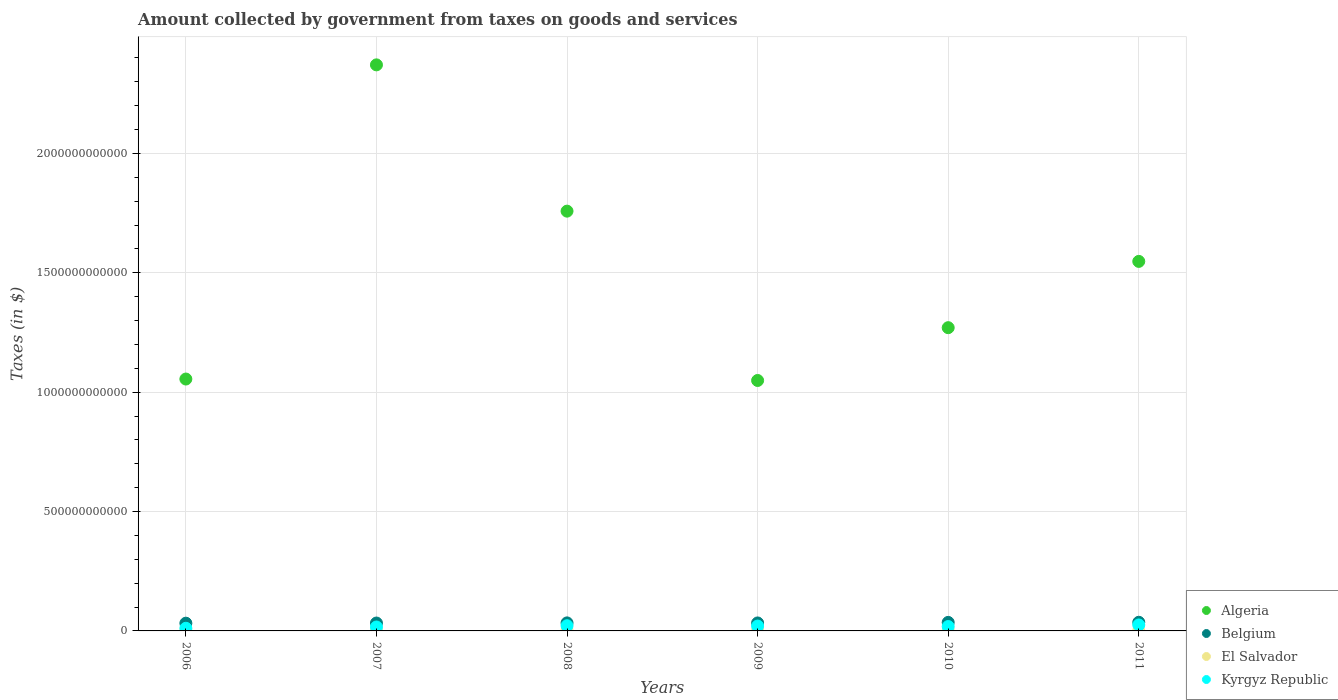How many different coloured dotlines are there?
Ensure brevity in your answer.  4. What is the amount collected by government from taxes on goods and services in El Salvador in 2011?
Provide a short and direct response. 1.69e+09. Across all years, what is the maximum amount collected by government from taxes on goods and services in El Salvador?
Your answer should be compact. 1.80e+09. Across all years, what is the minimum amount collected by government from taxes on goods and services in Kyrgyz Republic?
Your response must be concise. 1.11e+1. In which year was the amount collected by government from taxes on goods and services in El Salvador maximum?
Provide a short and direct response. 2008. What is the total amount collected by government from taxes on goods and services in Kyrgyz Republic in the graph?
Offer a very short reply. 1.13e+11. What is the difference between the amount collected by government from taxes on goods and services in El Salvador in 2007 and that in 2011?
Your response must be concise. -3.50e+07. What is the difference between the amount collected by government from taxes on goods and services in Algeria in 2007 and the amount collected by government from taxes on goods and services in Belgium in 2010?
Give a very brief answer. 2.34e+12. What is the average amount collected by government from taxes on goods and services in Kyrgyz Republic per year?
Offer a very short reply. 1.88e+1. In the year 2008, what is the difference between the amount collected by government from taxes on goods and services in Belgium and amount collected by government from taxes on goods and services in Kyrgyz Republic?
Provide a succinct answer. 1.19e+1. What is the ratio of the amount collected by government from taxes on goods and services in El Salvador in 2006 to that in 2011?
Offer a very short reply. 0.87. What is the difference between the highest and the second highest amount collected by government from taxes on goods and services in Algeria?
Keep it short and to the point. 6.13e+11. What is the difference between the highest and the lowest amount collected by government from taxes on goods and services in El Salvador?
Give a very brief answer. 3.62e+08. Is it the case that in every year, the sum of the amount collected by government from taxes on goods and services in Belgium and amount collected by government from taxes on goods and services in Algeria  is greater than the sum of amount collected by government from taxes on goods and services in Kyrgyz Republic and amount collected by government from taxes on goods and services in El Salvador?
Make the answer very short. Yes. Is it the case that in every year, the sum of the amount collected by government from taxes on goods and services in Belgium and amount collected by government from taxes on goods and services in Algeria  is greater than the amount collected by government from taxes on goods and services in Kyrgyz Republic?
Provide a short and direct response. Yes. Does the amount collected by government from taxes on goods and services in Kyrgyz Republic monotonically increase over the years?
Keep it short and to the point. No. Is the amount collected by government from taxes on goods and services in El Salvador strictly greater than the amount collected by government from taxes on goods and services in Belgium over the years?
Your response must be concise. No. Is the amount collected by government from taxes on goods and services in Belgium strictly less than the amount collected by government from taxes on goods and services in Kyrgyz Republic over the years?
Offer a very short reply. No. How many years are there in the graph?
Your answer should be very brief. 6. What is the difference between two consecutive major ticks on the Y-axis?
Offer a very short reply. 5.00e+11. Does the graph contain grids?
Provide a succinct answer. Yes. Where does the legend appear in the graph?
Provide a succinct answer. Bottom right. How many legend labels are there?
Your answer should be very brief. 4. What is the title of the graph?
Your response must be concise. Amount collected by government from taxes on goods and services. Does "Venezuela" appear as one of the legend labels in the graph?
Your response must be concise. No. What is the label or title of the X-axis?
Your response must be concise. Years. What is the label or title of the Y-axis?
Offer a very short reply. Taxes (in $). What is the Taxes (in $) in Algeria in 2006?
Give a very brief answer. 1.05e+12. What is the Taxes (in $) in Belgium in 2006?
Ensure brevity in your answer.  3.24e+1. What is the Taxes (in $) of El Salvador in 2006?
Give a very brief answer. 1.47e+09. What is the Taxes (in $) in Kyrgyz Republic in 2006?
Offer a very short reply. 1.11e+1. What is the Taxes (in $) of Algeria in 2007?
Your answer should be very brief. 2.37e+12. What is the Taxes (in $) of Belgium in 2007?
Keep it short and to the point. 3.31e+1. What is the Taxes (in $) in El Salvador in 2007?
Offer a very short reply. 1.66e+09. What is the Taxes (in $) of Kyrgyz Republic in 2007?
Your answer should be compact. 1.64e+1. What is the Taxes (in $) in Algeria in 2008?
Make the answer very short. 1.76e+12. What is the Taxes (in $) in Belgium in 2008?
Your response must be concise. 3.36e+1. What is the Taxes (in $) in El Salvador in 2008?
Ensure brevity in your answer.  1.80e+09. What is the Taxes (in $) in Kyrgyz Republic in 2008?
Ensure brevity in your answer.  2.18e+1. What is the Taxes (in $) of Algeria in 2009?
Make the answer very short. 1.05e+12. What is the Taxes (in $) of Belgium in 2009?
Offer a terse response. 3.34e+1. What is the Taxes (in $) of El Salvador in 2009?
Make the answer very short. 1.44e+09. What is the Taxes (in $) in Kyrgyz Republic in 2009?
Your answer should be compact. 2.04e+1. What is the Taxes (in $) of Algeria in 2010?
Give a very brief answer. 1.27e+12. What is the Taxes (in $) of Belgium in 2010?
Ensure brevity in your answer.  3.57e+1. What is the Taxes (in $) of El Salvador in 2010?
Offer a very short reply. 1.66e+09. What is the Taxes (in $) in Kyrgyz Republic in 2010?
Provide a short and direct response. 1.84e+1. What is the Taxes (in $) of Algeria in 2011?
Provide a short and direct response. 1.55e+12. What is the Taxes (in $) in Belgium in 2011?
Offer a terse response. 3.62e+1. What is the Taxes (in $) of El Salvador in 2011?
Your answer should be very brief. 1.69e+09. What is the Taxes (in $) of Kyrgyz Republic in 2011?
Offer a very short reply. 2.50e+1. Across all years, what is the maximum Taxes (in $) of Algeria?
Offer a terse response. 2.37e+12. Across all years, what is the maximum Taxes (in $) in Belgium?
Make the answer very short. 3.62e+1. Across all years, what is the maximum Taxes (in $) in El Salvador?
Provide a short and direct response. 1.80e+09. Across all years, what is the maximum Taxes (in $) in Kyrgyz Republic?
Provide a short and direct response. 2.50e+1. Across all years, what is the minimum Taxes (in $) of Algeria?
Offer a terse response. 1.05e+12. Across all years, what is the minimum Taxes (in $) of Belgium?
Offer a very short reply. 3.24e+1. Across all years, what is the minimum Taxes (in $) of El Salvador?
Provide a succinct answer. 1.44e+09. Across all years, what is the minimum Taxes (in $) in Kyrgyz Republic?
Your answer should be very brief. 1.11e+1. What is the total Taxes (in $) in Algeria in the graph?
Make the answer very short. 9.05e+12. What is the total Taxes (in $) of Belgium in the graph?
Offer a terse response. 2.04e+11. What is the total Taxes (in $) in El Salvador in the graph?
Your response must be concise. 9.73e+09. What is the total Taxes (in $) in Kyrgyz Republic in the graph?
Provide a short and direct response. 1.13e+11. What is the difference between the Taxes (in $) of Algeria in 2006 and that in 2007?
Provide a succinct answer. -1.32e+12. What is the difference between the Taxes (in $) of Belgium in 2006 and that in 2007?
Give a very brief answer. -6.23e+08. What is the difference between the Taxes (in $) in El Salvador in 2006 and that in 2007?
Keep it short and to the point. -1.86e+08. What is the difference between the Taxes (in $) of Kyrgyz Republic in 2006 and that in 2007?
Your answer should be very brief. -5.34e+09. What is the difference between the Taxes (in $) in Algeria in 2006 and that in 2008?
Your answer should be very brief. -7.03e+11. What is the difference between the Taxes (in $) of Belgium in 2006 and that in 2008?
Keep it short and to the point. -1.22e+09. What is the difference between the Taxes (in $) in El Salvador in 2006 and that in 2008?
Ensure brevity in your answer.  -3.30e+08. What is the difference between the Taxes (in $) of Kyrgyz Republic in 2006 and that in 2008?
Your answer should be compact. -1.07e+1. What is the difference between the Taxes (in $) in Algeria in 2006 and that in 2009?
Ensure brevity in your answer.  6.04e+09. What is the difference between the Taxes (in $) in Belgium in 2006 and that in 2009?
Your response must be concise. -9.86e+08. What is the difference between the Taxes (in $) in El Salvador in 2006 and that in 2009?
Provide a short and direct response. 3.19e+07. What is the difference between the Taxes (in $) in Kyrgyz Republic in 2006 and that in 2009?
Keep it short and to the point. -9.27e+09. What is the difference between the Taxes (in $) in Algeria in 2006 and that in 2010?
Offer a terse response. -2.15e+11. What is the difference between the Taxes (in $) of Belgium in 2006 and that in 2010?
Offer a terse response. -3.27e+09. What is the difference between the Taxes (in $) in El Salvador in 2006 and that in 2010?
Keep it short and to the point. -1.89e+08. What is the difference between the Taxes (in $) in Kyrgyz Republic in 2006 and that in 2010?
Your answer should be very brief. -7.29e+09. What is the difference between the Taxes (in $) in Algeria in 2006 and that in 2011?
Offer a terse response. -4.93e+11. What is the difference between the Taxes (in $) of Belgium in 2006 and that in 2011?
Give a very brief answer. -3.77e+09. What is the difference between the Taxes (in $) in El Salvador in 2006 and that in 2011?
Offer a terse response. -2.21e+08. What is the difference between the Taxes (in $) in Kyrgyz Republic in 2006 and that in 2011?
Ensure brevity in your answer.  -1.39e+1. What is the difference between the Taxes (in $) in Algeria in 2007 and that in 2008?
Give a very brief answer. 6.13e+11. What is the difference between the Taxes (in $) in Belgium in 2007 and that in 2008?
Ensure brevity in your answer.  -5.92e+08. What is the difference between the Taxes (in $) in El Salvador in 2007 and that in 2008?
Make the answer very short. -1.44e+08. What is the difference between the Taxes (in $) in Kyrgyz Republic in 2007 and that in 2008?
Make the answer very short. -5.35e+09. What is the difference between the Taxes (in $) of Algeria in 2007 and that in 2009?
Your response must be concise. 1.32e+12. What is the difference between the Taxes (in $) of Belgium in 2007 and that in 2009?
Ensure brevity in your answer.  -3.62e+08. What is the difference between the Taxes (in $) of El Salvador in 2007 and that in 2009?
Make the answer very short. 2.18e+08. What is the difference between the Taxes (in $) in Kyrgyz Republic in 2007 and that in 2009?
Offer a terse response. -3.93e+09. What is the difference between the Taxes (in $) in Algeria in 2007 and that in 2010?
Keep it short and to the point. 1.10e+12. What is the difference between the Taxes (in $) in Belgium in 2007 and that in 2010?
Your response must be concise. -2.65e+09. What is the difference between the Taxes (in $) in El Salvador in 2007 and that in 2010?
Ensure brevity in your answer.  -2.90e+06. What is the difference between the Taxes (in $) in Kyrgyz Republic in 2007 and that in 2010?
Ensure brevity in your answer.  -1.95e+09. What is the difference between the Taxes (in $) in Algeria in 2007 and that in 2011?
Your answer should be very brief. 8.23e+11. What is the difference between the Taxes (in $) in Belgium in 2007 and that in 2011?
Ensure brevity in your answer.  -3.14e+09. What is the difference between the Taxes (in $) in El Salvador in 2007 and that in 2011?
Give a very brief answer. -3.50e+07. What is the difference between the Taxes (in $) of Kyrgyz Republic in 2007 and that in 2011?
Provide a short and direct response. -8.56e+09. What is the difference between the Taxes (in $) of Algeria in 2008 and that in 2009?
Your response must be concise. 7.09e+11. What is the difference between the Taxes (in $) of Belgium in 2008 and that in 2009?
Make the answer very short. 2.30e+08. What is the difference between the Taxes (in $) of El Salvador in 2008 and that in 2009?
Give a very brief answer. 3.62e+08. What is the difference between the Taxes (in $) in Kyrgyz Republic in 2008 and that in 2009?
Your response must be concise. 1.42e+09. What is the difference between the Taxes (in $) of Algeria in 2008 and that in 2010?
Offer a very short reply. 4.88e+11. What is the difference between the Taxes (in $) in Belgium in 2008 and that in 2010?
Provide a succinct answer. -2.06e+09. What is the difference between the Taxes (in $) of El Salvador in 2008 and that in 2010?
Your answer should be compact. 1.41e+08. What is the difference between the Taxes (in $) in Kyrgyz Republic in 2008 and that in 2010?
Offer a terse response. 3.40e+09. What is the difference between the Taxes (in $) of Algeria in 2008 and that in 2011?
Provide a succinct answer. 2.10e+11. What is the difference between the Taxes (in $) in Belgium in 2008 and that in 2011?
Give a very brief answer. -2.55e+09. What is the difference between the Taxes (in $) of El Salvador in 2008 and that in 2011?
Your answer should be compact. 1.09e+08. What is the difference between the Taxes (in $) of Kyrgyz Republic in 2008 and that in 2011?
Your answer should be compact. -3.21e+09. What is the difference between the Taxes (in $) of Algeria in 2009 and that in 2010?
Your answer should be very brief. -2.21e+11. What is the difference between the Taxes (in $) in Belgium in 2009 and that in 2010?
Your answer should be compact. -2.29e+09. What is the difference between the Taxes (in $) of El Salvador in 2009 and that in 2010?
Provide a short and direct response. -2.20e+08. What is the difference between the Taxes (in $) in Kyrgyz Republic in 2009 and that in 2010?
Offer a very short reply. 1.98e+09. What is the difference between the Taxes (in $) in Algeria in 2009 and that in 2011?
Your answer should be very brief. -4.99e+11. What is the difference between the Taxes (in $) of Belgium in 2009 and that in 2011?
Ensure brevity in your answer.  -2.78e+09. What is the difference between the Taxes (in $) in El Salvador in 2009 and that in 2011?
Offer a very short reply. -2.53e+08. What is the difference between the Taxes (in $) of Kyrgyz Republic in 2009 and that in 2011?
Give a very brief answer. -4.63e+09. What is the difference between the Taxes (in $) of Algeria in 2010 and that in 2011?
Ensure brevity in your answer.  -2.78e+11. What is the difference between the Taxes (in $) in Belgium in 2010 and that in 2011?
Offer a terse response. -4.96e+08. What is the difference between the Taxes (in $) of El Salvador in 2010 and that in 2011?
Your response must be concise. -3.20e+07. What is the difference between the Taxes (in $) in Kyrgyz Republic in 2010 and that in 2011?
Provide a succinct answer. -6.61e+09. What is the difference between the Taxes (in $) of Algeria in 2006 and the Taxes (in $) of Belgium in 2007?
Offer a very short reply. 1.02e+12. What is the difference between the Taxes (in $) in Algeria in 2006 and the Taxes (in $) in El Salvador in 2007?
Give a very brief answer. 1.05e+12. What is the difference between the Taxes (in $) in Algeria in 2006 and the Taxes (in $) in Kyrgyz Republic in 2007?
Your answer should be compact. 1.04e+12. What is the difference between the Taxes (in $) in Belgium in 2006 and the Taxes (in $) in El Salvador in 2007?
Ensure brevity in your answer.  3.08e+1. What is the difference between the Taxes (in $) of Belgium in 2006 and the Taxes (in $) of Kyrgyz Republic in 2007?
Your answer should be very brief. 1.60e+1. What is the difference between the Taxes (in $) in El Salvador in 2006 and the Taxes (in $) in Kyrgyz Republic in 2007?
Make the answer very short. -1.50e+1. What is the difference between the Taxes (in $) of Algeria in 2006 and the Taxes (in $) of Belgium in 2008?
Keep it short and to the point. 1.02e+12. What is the difference between the Taxes (in $) of Algeria in 2006 and the Taxes (in $) of El Salvador in 2008?
Provide a short and direct response. 1.05e+12. What is the difference between the Taxes (in $) of Algeria in 2006 and the Taxes (in $) of Kyrgyz Republic in 2008?
Ensure brevity in your answer.  1.03e+12. What is the difference between the Taxes (in $) of Belgium in 2006 and the Taxes (in $) of El Salvador in 2008?
Your answer should be very brief. 3.06e+1. What is the difference between the Taxes (in $) in Belgium in 2006 and the Taxes (in $) in Kyrgyz Republic in 2008?
Ensure brevity in your answer.  1.06e+1. What is the difference between the Taxes (in $) of El Salvador in 2006 and the Taxes (in $) of Kyrgyz Republic in 2008?
Keep it short and to the point. -2.03e+1. What is the difference between the Taxes (in $) in Algeria in 2006 and the Taxes (in $) in Belgium in 2009?
Your answer should be very brief. 1.02e+12. What is the difference between the Taxes (in $) in Algeria in 2006 and the Taxes (in $) in El Salvador in 2009?
Make the answer very short. 1.05e+12. What is the difference between the Taxes (in $) in Algeria in 2006 and the Taxes (in $) in Kyrgyz Republic in 2009?
Offer a very short reply. 1.03e+12. What is the difference between the Taxes (in $) of Belgium in 2006 and the Taxes (in $) of El Salvador in 2009?
Make the answer very short. 3.10e+1. What is the difference between the Taxes (in $) in Belgium in 2006 and the Taxes (in $) in Kyrgyz Republic in 2009?
Provide a succinct answer. 1.21e+1. What is the difference between the Taxes (in $) in El Salvador in 2006 and the Taxes (in $) in Kyrgyz Republic in 2009?
Offer a very short reply. -1.89e+1. What is the difference between the Taxes (in $) of Algeria in 2006 and the Taxes (in $) of Belgium in 2010?
Your answer should be compact. 1.02e+12. What is the difference between the Taxes (in $) of Algeria in 2006 and the Taxes (in $) of El Salvador in 2010?
Your answer should be very brief. 1.05e+12. What is the difference between the Taxes (in $) in Algeria in 2006 and the Taxes (in $) in Kyrgyz Republic in 2010?
Your answer should be compact. 1.04e+12. What is the difference between the Taxes (in $) of Belgium in 2006 and the Taxes (in $) of El Salvador in 2010?
Make the answer very short. 3.08e+1. What is the difference between the Taxes (in $) in Belgium in 2006 and the Taxes (in $) in Kyrgyz Republic in 2010?
Make the answer very short. 1.40e+1. What is the difference between the Taxes (in $) in El Salvador in 2006 and the Taxes (in $) in Kyrgyz Republic in 2010?
Your response must be concise. -1.69e+1. What is the difference between the Taxes (in $) of Algeria in 2006 and the Taxes (in $) of Belgium in 2011?
Your answer should be very brief. 1.02e+12. What is the difference between the Taxes (in $) of Algeria in 2006 and the Taxes (in $) of El Salvador in 2011?
Make the answer very short. 1.05e+12. What is the difference between the Taxes (in $) of Algeria in 2006 and the Taxes (in $) of Kyrgyz Republic in 2011?
Give a very brief answer. 1.03e+12. What is the difference between the Taxes (in $) in Belgium in 2006 and the Taxes (in $) in El Salvador in 2011?
Your answer should be very brief. 3.07e+1. What is the difference between the Taxes (in $) of Belgium in 2006 and the Taxes (in $) of Kyrgyz Republic in 2011?
Give a very brief answer. 7.43e+09. What is the difference between the Taxes (in $) in El Salvador in 2006 and the Taxes (in $) in Kyrgyz Republic in 2011?
Your answer should be compact. -2.35e+1. What is the difference between the Taxes (in $) in Algeria in 2007 and the Taxes (in $) in Belgium in 2008?
Offer a terse response. 2.34e+12. What is the difference between the Taxes (in $) in Algeria in 2007 and the Taxes (in $) in El Salvador in 2008?
Ensure brevity in your answer.  2.37e+12. What is the difference between the Taxes (in $) in Algeria in 2007 and the Taxes (in $) in Kyrgyz Republic in 2008?
Your answer should be compact. 2.35e+12. What is the difference between the Taxes (in $) in Belgium in 2007 and the Taxes (in $) in El Salvador in 2008?
Your response must be concise. 3.12e+1. What is the difference between the Taxes (in $) in Belgium in 2007 and the Taxes (in $) in Kyrgyz Republic in 2008?
Make the answer very short. 1.13e+1. What is the difference between the Taxes (in $) of El Salvador in 2007 and the Taxes (in $) of Kyrgyz Republic in 2008?
Keep it short and to the point. -2.01e+1. What is the difference between the Taxes (in $) in Algeria in 2007 and the Taxes (in $) in Belgium in 2009?
Provide a succinct answer. 2.34e+12. What is the difference between the Taxes (in $) in Algeria in 2007 and the Taxes (in $) in El Salvador in 2009?
Your answer should be compact. 2.37e+12. What is the difference between the Taxes (in $) of Algeria in 2007 and the Taxes (in $) of Kyrgyz Republic in 2009?
Keep it short and to the point. 2.35e+12. What is the difference between the Taxes (in $) of Belgium in 2007 and the Taxes (in $) of El Salvador in 2009?
Keep it short and to the point. 3.16e+1. What is the difference between the Taxes (in $) in Belgium in 2007 and the Taxes (in $) in Kyrgyz Republic in 2009?
Provide a succinct answer. 1.27e+1. What is the difference between the Taxes (in $) of El Salvador in 2007 and the Taxes (in $) of Kyrgyz Republic in 2009?
Offer a terse response. -1.87e+1. What is the difference between the Taxes (in $) of Algeria in 2007 and the Taxes (in $) of Belgium in 2010?
Ensure brevity in your answer.  2.34e+12. What is the difference between the Taxes (in $) of Algeria in 2007 and the Taxes (in $) of El Salvador in 2010?
Ensure brevity in your answer.  2.37e+12. What is the difference between the Taxes (in $) of Algeria in 2007 and the Taxes (in $) of Kyrgyz Republic in 2010?
Offer a terse response. 2.35e+12. What is the difference between the Taxes (in $) of Belgium in 2007 and the Taxes (in $) of El Salvador in 2010?
Provide a short and direct response. 3.14e+1. What is the difference between the Taxes (in $) of Belgium in 2007 and the Taxes (in $) of Kyrgyz Republic in 2010?
Give a very brief answer. 1.47e+1. What is the difference between the Taxes (in $) in El Salvador in 2007 and the Taxes (in $) in Kyrgyz Republic in 2010?
Offer a terse response. -1.67e+1. What is the difference between the Taxes (in $) of Algeria in 2007 and the Taxes (in $) of Belgium in 2011?
Your response must be concise. 2.33e+12. What is the difference between the Taxes (in $) of Algeria in 2007 and the Taxes (in $) of El Salvador in 2011?
Offer a very short reply. 2.37e+12. What is the difference between the Taxes (in $) in Algeria in 2007 and the Taxes (in $) in Kyrgyz Republic in 2011?
Ensure brevity in your answer.  2.35e+12. What is the difference between the Taxes (in $) of Belgium in 2007 and the Taxes (in $) of El Salvador in 2011?
Offer a terse response. 3.14e+1. What is the difference between the Taxes (in $) in Belgium in 2007 and the Taxes (in $) in Kyrgyz Republic in 2011?
Make the answer very short. 8.05e+09. What is the difference between the Taxes (in $) in El Salvador in 2007 and the Taxes (in $) in Kyrgyz Republic in 2011?
Give a very brief answer. -2.33e+1. What is the difference between the Taxes (in $) of Algeria in 2008 and the Taxes (in $) of Belgium in 2009?
Give a very brief answer. 1.72e+12. What is the difference between the Taxes (in $) of Algeria in 2008 and the Taxes (in $) of El Salvador in 2009?
Provide a succinct answer. 1.76e+12. What is the difference between the Taxes (in $) in Algeria in 2008 and the Taxes (in $) in Kyrgyz Republic in 2009?
Keep it short and to the point. 1.74e+12. What is the difference between the Taxes (in $) in Belgium in 2008 and the Taxes (in $) in El Salvador in 2009?
Keep it short and to the point. 3.22e+1. What is the difference between the Taxes (in $) in Belgium in 2008 and the Taxes (in $) in Kyrgyz Republic in 2009?
Provide a succinct answer. 1.33e+1. What is the difference between the Taxes (in $) in El Salvador in 2008 and the Taxes (in $) in Kyrgyz Republic in 2009?
Your answer should be compact. -1.86e+1. What is the difference between the Taxes (in $) of Algeria in 2008 and the Taxes (in $) of Belgium in 2010?
Provide a short and direct response. 1.72e+12. What is the difference between the Taxes (in $) in Algeria in 2008 and the Taxes (in $) in El Salvador in 2010?
Your answer should be compact. 1.76e+12. What is the difference between the Taxes (in $) of Algeria in 2008 and the Taxes (in $) of Kyrgyz Republic in 2010?
Your answer should be compact. 1.74e+12. What is the difference between the Taxes (in $) in Belgium in 2008 and the Taxes (in $) in El Salvador in 2010?
Offer a very short reply. 3.20e+1. What is the difference between the Taxes (in $) in Belgium in 2008 and the Taxes (in $) in Kyrgyz Republic in 2010?
Offer a terse response. 1.53e+1. What is the difference between the Taxes (in $) of El Salvador in 2008 and the Taxes (in $) of Kyrgyz Republic in 2010?
Give a very brief answer. -1.66e+1. What is the difference between the Taxes (in $) of Algeria in 2008 and the Taxes (in $) of Belgium in 2011?
Provide a short and direct response. 1.72e+12. What is the difference between the Taxes (in $) in Algeria in 2008 and the Taxes (in $) in El Salvador in 2011?
Your answer should be very brief. 1.76e+12. What is the difference between the Taxes (in $) of Algeria in 2008 and the Taxes (in $) of Kyrgyz Republic in 2011?
Provide a short and direct response. 1.73e+12. What is the difference between the Taxes (in $) of Belgium in 2008 and the Taxes (in $) of El Salvador in 2011?
Provide a short and direct response. 3.20e+1. What is the difference between the Taxes (in $) in Belgium in 2008 and the Taxes (in $) in Kyrgyz Republic in 2011?
Your response must be concise. 8.64e+09. What is the difference between the Taxes (in $) in El Salvador in 2008 and the Taxes (in $) in Kyrgyz Republic in 2011?
Keep it short and to the point. -2.32e+1. What is the difference between the Taxes (in $) in Algeria in 2009 and the Taxes (in $) in Belgium in 2010?
Your answer should be very brief. 1.01e+12. What is the difference between the Taxes (in $) of Algeria in 2009 and the Taxes (in $) of El Salvador in 2010?
Offer a terse response. 1.05e+12. What is the difference between the Taxes (in $) of Algeria in 2009 and the Taxes (in $) of Kyrgyz Republic in 2010?
Ensure brevity in your answer.  1.03e+12. What is the difference between the Taxes (in $) in Belgium in 2009 and the Taxes (in $) in El Salvador in 2010?
Keep it short and to the point. 3.18e+1. What is the difference between the Taxes (in $) in Belgium in 2009 and the Taxes (in $) in Kyrgyz Republic in 2010?
Your answer should be very brief. 1.50e+1. What is the difference between the Taxes (in $) of El Salvador in 2009 and the Taxes (in $) of Kyrgyz Republic in 2010?
Provide a short and direct response. -1.69e+1. What is the difference between the Taxes (in $) in Algeria in 2009 and the Taxes (in $) in Belgium in 2011?
Provide a succinct answer. 1.01e+12. What is the difference between the Taxes (in $) in Algeria in 2009 and the Taxes (in $) in El Salvador in 2011?
Offer a very short reply. 1.05e+12. What is the difference between the Taxes (in $) in Algeria in 2009 and the Taxes (in $) in Kyrgyz Republic in 2011?
Provide a short and direct response. 1.02e+12. What is the difference between the Taxes (in $) of Belgium in 2009 and the Taxes (in $) of El Salvador in 2011?
Give a very brief answer. 3.17e+1. What is the difference between the Taxes (in $) in Belgium in 2009 and the Taxes (in $) in Kyrgyz Republic in 2011?
Give a very brief answer. 8.41e+09. What is the difference between the Taxes (in $) in El Salvador in 2009 and the Taxes (in $) in Kyrgyz Republic in 2011?
Provide a succinct answer. -2.36e+1. What is the difference between the Taxes (in $) of Algeria in 2010 and the Taxes (in $) of Belgium in 2011?
Keep it short and to the point. 1.23e+12. What is the difference between the Taxes (in $) in Algeria in 2010 and the Taxes (in $) in El Salvador in 2011?
Give a very brief answer. 1.27e+12. What is the difference between the Taxes (in $) in Algeria in 2010 and the Taxes (in $) in Kyrgyz Republic in 2011?
Give a very brief answer. 1.25e+12. What is the difference between the Taxes (in $) of Belgium in 2010 and the Taxes (in $) of El Salvador in 2011?
Make the answer very short. 3.40e+1. What is the difference between the Taxes (in $) in Belgium in 2010 and the Taxes (in $) in Kyrgyz Republic in 2011?
Provide a short and direct response. 1.07e+1. What is the difference between the Taxes (in $) of El Salvador in 2010 and the Taxes (in $) of Kyrgyz Republic in 2011?
Give a very brief answer. -2.33e+1. What is the average Taxes (in $) in Algeria per year?
Provide a short and direct response. 1.51e+12. What is the average Taxes (in $) of Belgium per year?
Offer a terse response. 3.41e+1. What is the average Taxes (in $) in El Salvador per year?
Your answer should be compact. 1.62e+09. What is the average Taxes (in $) of Kyrgyz Republic per year?
Provide a succinct answer. 1.88e+1. In the year 2006, what is the difference between the Taxes (in $) in Algeria and Taxes (in $) in Belgium?
Offer a terse response. 1.02e+12. In the year 2006, what is the difference between the Taxes (in $) in Algeria and Taxes (in $) in El Salvador?
Ensure brevity in your answer.  1.05e+12. In the year 2006, what is the difference between the Taxes (in $) in Algeria and Taxes (in $) in Kyrgyz Republic?
Make the answer very short. 1.04e+12. In the year 2006, what is the difference between the Taxes (in $) of Belgium and Taxes (in $) of El Salvador?
Offer a terse response. 3.10e+1. In the year 2006, what is the difference between the Taxes (in $) in Belgium and Taxes (in $) in Kyrgyz Republic?
Provide a succinct answer. 2.13e+1. In the year 2006, what is the difference between the Taxes (in $) of El Salvador and Taxes (in $) of Kyrgyz Republic?
Offer a terse response. -9.63e+09. In the year 2007, what is the difference between the Taxes (in $) in Algeria and Taxes (in $) in Belgium?
Your answer should be very brief. 2.34e+12. In the year 2007, what is the difference between the Taxes (in $) of Algeria and Taxes (in $) of El Salvador?
Offer a terse response. 2.37e+12. In the year 2007, what is the difference between the Taxes (in $) of Algeria and Taxes (in $) of Kyrgyz Republic?
Give a very brief answer. 2.35e+12. In the year 2007, what is the difference between the Taxes (in $) of Belgium and Taxes (in $) of El Salvador?
Your answer should be compact. 3.14e+1. In the year 2007, what is the difference between the Taxes (in $) in Belgium and Taxes (in $) in Kyrgyz Republic?
Provide a succinct answer. 1.66e+1. In the year 2007, what is the difference between the Taxes (in $) in El Salvador and Taxes (in $) in Kyrgyz Republic?
Provide a short and direct response. -1.48e+1. In the year 2008, what is the difference between the Taxes (in $) of Algeria and Taxes (in $) of Belgium?
Ensure brevity in your answer.  1.72e+12. In the year 2008, what is the difference between the Taxes (in $) of Algeria and Taxes (in $) of El Salvador?
Make the answer very short. 1.76e+12. In the year 2008, what is the difference between the Taxes (in $) of Algeria and Taxes (in $) of Kyrgyz Republic?
Your answer should be compact. 1.74e+12. In the year 2008, what is the difference between the Taxes (in $) in Belgium and Taxes (in $) in El Salvador?
Keep it short and to the point. 3.18e+1. In the year 2008, what is the difference between the Taxes (in $) of Belgium and Taxes (in $) of Kyrgyz Republic?
Keep it short and to the point. 1.19e+1. In the year 2008, what is the difference between the Taxes (in $) in El Salvador and Taxes (in $) in Kyrgyz Republic?
Give a very brief answer. -2.00e+1. In the year 2009, what is the difference between the Taxes (in $) in Algeria and Taxes (in $) in Belgium?
Make the answer very short. 1.02e+12. In the year 2009, what is the difference between the Taxes (in $) in Algeria and Taxes (in $) in El Salvador?
Make the answer very short. 1.05e+12. In the year 2009, what is the difference between the Taxes (in $) in Algeria and Taxes (in $) in Kyrgyz Republic?
Offer a very short reply. 1.03e+12. In the year 2009, what is the difference between the Taxes (in $) in Belgium and Taxes (in $) in El Salvador?
Give a very brief answer. 3.20e+1. In the year 2009, what is the difference between the Taxes (in $) of Belgium and Taxes (in $) of Kyrgyz Republic?
Offer a terse response. 1.30e+1. In the year 2009, what is the difference between the Taxes (in $) of El Salvador and Taxes (in $) of Kyrgyz Republic?
Your answer should be compact. -1.89e+1. In the year 2010, what is the difference between the Taxes (in $) in Algeria and Taxes (in $) in Belgium?
Keep it short and to the point. 1.23e+12. In the year 2010, what is the difference between the Taxes (in $) of Algeria and Taxes (in $) of El Salvador?
Give a very brief answer. 1.27e+12. In the year 2010, what is the difference between the Taxes (in $) of Algeria and Taxes (in $) of Kyrgyz Republic?
Ensure brevity in your answer.  1.25e+12. In the year 2010, what is the difference between the Taxes (in $) of Belgium and Taxes (in $) of El Salvador?
Keep it short and to the point. 3.40e+1. In the year 2010, what is the difference between the Taxes (in $) of Belgium and Taxes (in $) of Kyrgyz Republic?
Your answer should be very brief. 1.73e+1. In the year 2010, what is the difference between the Taxes (in $) in El Salvador and Taxes (in $) in Kyrgyz Republic?
Your answer should be very brief. -1.67e+1. In the year 2011, what is the difference between the Taxes (in $) of Algeria and Taxes (in $) of Belgium?
Provide a short and direct response. 1.51e+12. In the year 2011, what is the difference between the Taxes (in $) in Algeria and Taxes (in $) in El Salvador?
Ensure brevity in your answer.  1.55e+12. In the year 2011, what is the difference between the Taxes (in $) in Algeria and Taxes (in $) in Kyrgyz Republic?
Provide a succinct answer. 1.52e+12. In the year 2011, what is the difference between the Taxes (in $) of Belgium and Taxes (in $) of El Salvador?
Provide a succinct answer. 3.45e+1. In the year 2011, what is the difference between the Taxes (in $) in Belgium and Taxes (in $) in Kyrgyz Republic?
Ensure brevity in your answer.  1.12e+1. In the year 2011, what is the difference between the Taxes (in $) in El Salvador and Taxes (in $) in Kyrgyz Republic?
Provide a succinct answer. -2.33e+1. What is the ratio of the Taxes (in $) of Algeria in 2006 to that in 2007?
Provide a short and direct response. 0.45. What is the ratio of the Taxes (in $) in Belgium in 2006 to that in 2007?
Provide a succinct answer. 0.98. What is the ratio of the Taxes (in $) in El Salvador in 2006 to that in 2007?
Offer a terse response. 0.89. What is the ratio of the Taxes (in $) in Kyrgyz Republic in 2006 to that in 2007?
Ensure brevity in your answer.  0.68. What is the ratio of the Taxes (in $) of Belgium in 2006 to that in 2008?
Your answer should be compact. 0.96. What is the ratio of the Taxes (in $) of El Salvador in 2006 to that in 2008?
Provide a succinct answer. 0.82. What is the ratio of the Taxes (in $) in Kyrgyz Republic in 2006 to that in 2008?
Your response must be concise. 0.51. What is the ratio of the Taxes (in $) of Algeria in 2006 to that in 2009?
Give a very brief answer. 1.01. What is the ratio of the Taxes (in $) in Belgium in 2006 to that in 2009?
Make the answer very short. 0.97. What is the ratio of the Taxes (in $) of El Salvador in 2006 to that in 2009?
Provide a short and direct response. 1.02. What is the ratio of the Taxes (in $) in Kyrgyz Republic in 2006 to that in 2009?
Offer a terse response. 0.55. What is the ratio of the Taxes (in $) of Algeria in 2006 to that in 2010?
Make the answer very short. 0.83. What is the ratio of the Taxes (in $) of Belgium in 2006 to that in 2010?
Keep it short and to the point. 0.91. What is the ratio of the Taxes (in $) of El Salvador in 2006 to that in 2010?
Make the answer very short. 0.89. What is the ratio of the Taxes (in $) of Kyrgyz Republic in 2006 to that in 2010?
Provide a succinct answer. 0.6. What is the ratio of the Taxes (in $) in Algeria in 2006 to that in 2011?
Provide a succinct answer. 0.68. What is the ratio of the Taxes (in $) of Belgium in 2006 to that in 2011?
Provide a succinct answer. 0.9. What is the ratio of the Taxes (in $) in El Salvador in 2006 to that in 2011?
Ensure brevity in your answer.  0.87. What is the ratio of the Taxes (in $) in Kyrgyz Republic in 2006 to that in 2011?
Ensure brevity in your answer.  0.44. What is the ratio of the Taxes (in $) of Algeria in 2007 to that in 2008?
Ensure brevity in your answer.  1.35. What is the ratio of the Taxes (in $) in Belgium in 2007 to that in 2008?
Your answer should be compact. 0.98. What is the ratio of the Taxes (in $) of El Salvador in 2007 to that in 2008?
Provide a short and direct response. 0.92. What is the ratio of the Taxes (in $) in Kyrgyz Republic in 2007 to that in 2008?
Your answer should be compact. 0.75. What is the ratio of the Taxes (in $) of Algeria in 2007 to that in 2009?
Your answer should be compact. 2.26. What is the ratio of the Taxes (in $) in El Salvador in 2007 to that in 2009?
Keep it short and to the point. 1.15. What is the ratio of the Taxes (in $) of Kyrgyz Republic in 2007 to that in 2009?
Keep it short and to the point. 0.81. What is the ratio of the Taxes (in $) of Algeria in 2007 to that in 2010?
Offer a very short reply. 1.87. What is the ratio of the Taxes (in $) of Belgium in 2007 to that in 2010?
Ensure brevity in your answer.  0.93. What is the ratio of the Taxes (in $) in El Salvador in 2007 to that in 2010?
Your answer should be very brief. 1. What is the ratio of the Taxes (in $) of Kyrgyz Republic in 2007 to that in 2010?
Your answer should be compact. 0.89. What is the ratio of the Taxes (in $) in Algeria in 2007 to that in 2011?
Your answer should be very brief. 1.53. What is the ratio of the Taxes (in $) in Belgium in 2007 to that in 2011?
Your response must be concise. 0.91. What is the ratio of the Taxes (in $) of El Salvador in 2007 to that in 2011?
Provide a succinct answer. 0.98. What is the ratio of the Taxes (in $) in Kyrgyz Republic in 2007 to that in 2011?
Ensure brevity in your answer.  0.66. What is the ratio of the Taxes (in $) of Algeria in 2008 to that in 2009?
Provide a short and direct response. 1.68. What is the ratio of the Taxes (in $) in Belgium in 2008 to that in 2009?
Provide a short and direct response. 1.01. What is the ratio of the Taxes (in $) of El Salvador in 2008 to that in 2009?
Your answer should be compact. 1.25. What is the ratio of the Taxes (in $) in Kyrgyz Republic in 2008 to that in 2009?
Give a very brief answer. 1.07. What is the ratio of the Taxes (in $) of Algeria in 2008 to that in 2010?
Offer a terse response. 1.38. What is the ratio of the Taxes (in $) in Belgium in 2008 to that in 2010?
Offer a terse response. 0.94. What is the ratio of the Taxes (in $) in El Salvador in 2008 to that in 2010?
Keep it short and to the point. 1.09. What is the ratio of the Taxes (in $) in Kyrgyz Republic in 2008 to that in 2010?
Your answer should be compact. 1.18. What is the ratio of the Taxes (in $) in Algeria in 2008 to that in 2011?
Provide a short and direct response. 1.14. What is the ratio of the Taxes (in $) in Belgium in 2008 to that in 2011?
Your answer should be very brief. 0.93. What is the ratio of the Taxes (in $) of El Salvador in 2008 to that in 2011?
Make the answer very short. 1.06. What is the ratio of the Taxes (in $) in Kyrgyz Republic in 2008 to that in 2011?
Keep it short and to the point. 0.87. What is the ratio of the Taxes (in $) of Algeria in 2009 to that in 2010?
Ensure brevity in your answer.  0.83. What is the ratio of the Taxes (in $) of Belgium in 2009 to that in 2010?
Provide a succinct answer. 0.94. What is the ratio of the Taxes (in $) of El Salvador in 2009 to that in 2010?
Provide a succinct answer. 0.87. What is the ratio of the Taxes (in $) of Kyrgyz Republic in 2009 to that in 2010?
Your answer should be compact. 1.11. What is the ratio of the Taxes (in $) of Algeria in 2009 to that in 2011?
Your answer should be very brief. 0.68. What is the ratio of the Taxes (in $) in El Salvador in 2009 to that in 2011?
Make the answer very short. 0.85. What is the ratio of the Taxes (in $) in Kyrgyz Republic in 2009 to that in 2011?
Offer a terse response. 0.81. What is the ratio of the Taxes (in $) in Algeria in 2010 to that in 2011?
Your answer should be very brief. 0.82. What is the ratio of the Taxes (in $) of Belgium in 2010 to that in 2011?
Offer a terse response. 0.99. What is the ratio of the Taxes (in $) of El Salvador in 2010 to that in 2011?
Keep it short and to the point. 0.98. What is the ratio of the Taxes (in $) of Kyrgyz Republic in 2010 to that in 2011?
Provide a succinct answer. 0.74. What is the difference between the highest and the second highest Taxes (in $) of Algeria?
Make the answer very short. 6.13e+11. What is the difference between the highest and the second highest Taxes (in $) in Belgium?
Ensure brevity in your answer.  4.96e+08. What is the difference between the highest and the second highest Taxes (in $) in El Salvador?
Your answer should be very brief. 1.09e+08. What is the difference between the highest and the second highest Taxes (in $) of Kyrgyz Republic?
Provide a short and direct response. 3.21e+09. What is the difference between the highest and the lowest Taxes (in $) of Algeria?
Give a very brief answer. 1.32e+12. What is the difference between the highest and the lowest Taxes (in $) in Belgium?
Your response must be concise. 3.77e+09. What is the difference between the highest and the lowest Taxes (in $) in El Salvador?
Give a very brief answer. 3.62e+08. What is the difference between the highest and the lowest Taxes (in $) of Kyrgyz Republic?
Provide a succinct answer. 1.39e+1. 